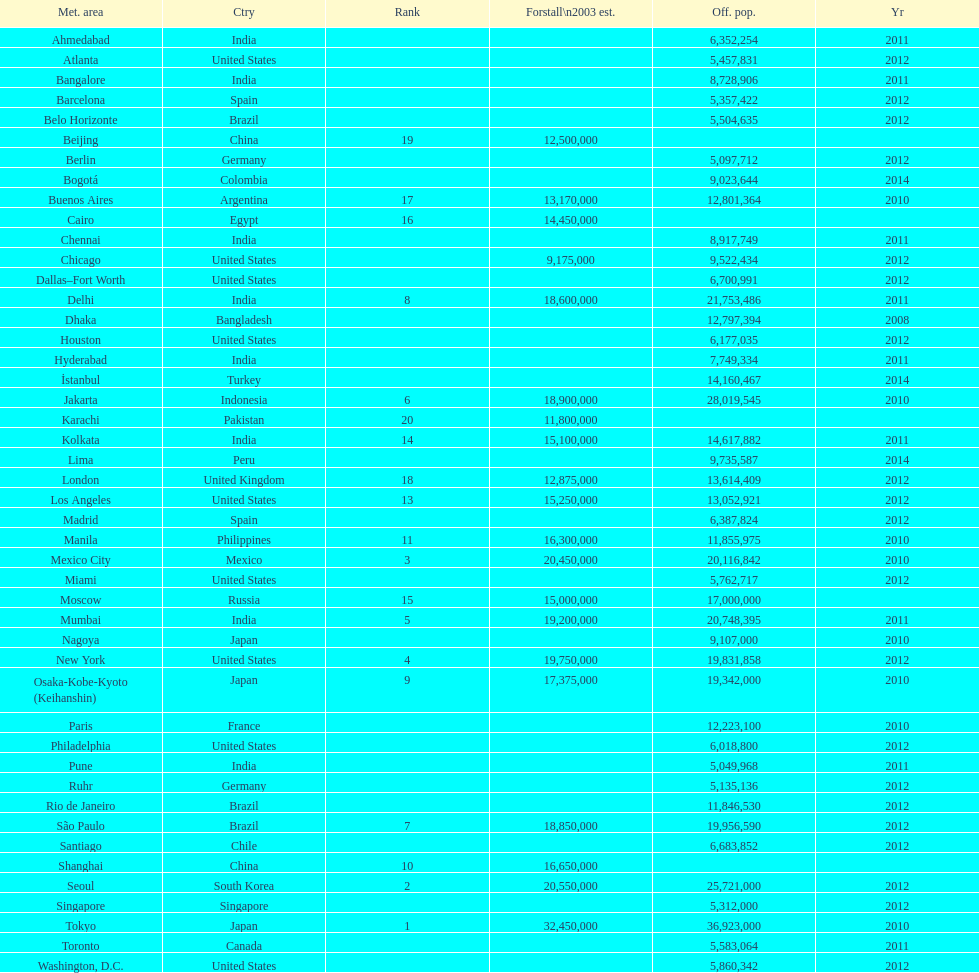What city was ranked first in 2003? Tokyo. 